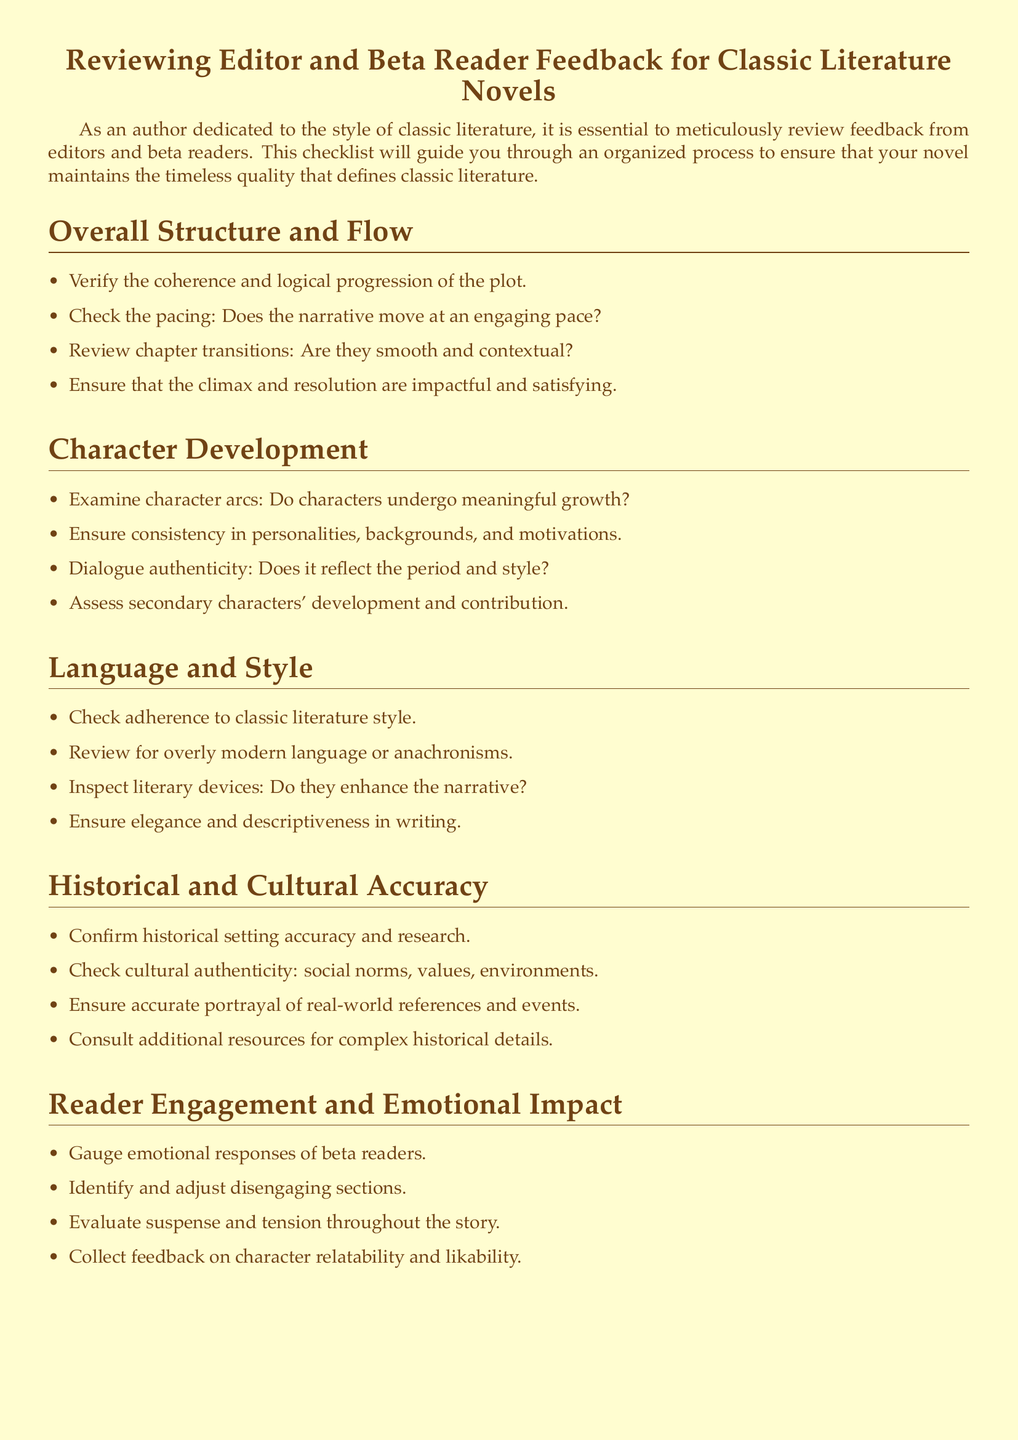What are the components of the checklist? The checklist includes sections on Overall Structure and Flow, Character Development, Language and Style, Historical and Cultural Accuracy, Reader Engagement and Emotional Impact, and Technical Accuracy and Grammar.
Answer: Overall Structure and Flow, Character Development, Language and Style, Historical and Cultural Accuracy, Reader Engagement and Emotional Impact, Technical Accuracy and Grammar How many questions are listed under Language and Style? The section on Language and Style contains four items for review.
Answer: 4 What aspect does the checklist emphasize for character arcs? The checklist emphasizes that characters should undergo meaningful growth.
Answer: Meaningful growth What is the recommended approach for checking historical setting accuracy? The document suggests confirming historical setting accuracy and conducting research.
Answer: Confirming accuracy and research Which section addresses the engagement and emotional impact on readers? The section titled "Reader Engagement and Emotional Impact" focuses on this aspect.
Answer: Reader Engagement and Emotional Impact What should be examined for dialogue authenticity? The checklist states that dialogue should reflect the period and style for authenticity.
Answer: Reflect the period and style How is the elegance of the writing assessed? The checklist states that writing should be elegant and descriptive.
Answer: Elegant and descriptive What is the purpose of consulting additional resources? Additional resources should be consulted for complex historical details based on the checklist.
Answer: Complex historical details 